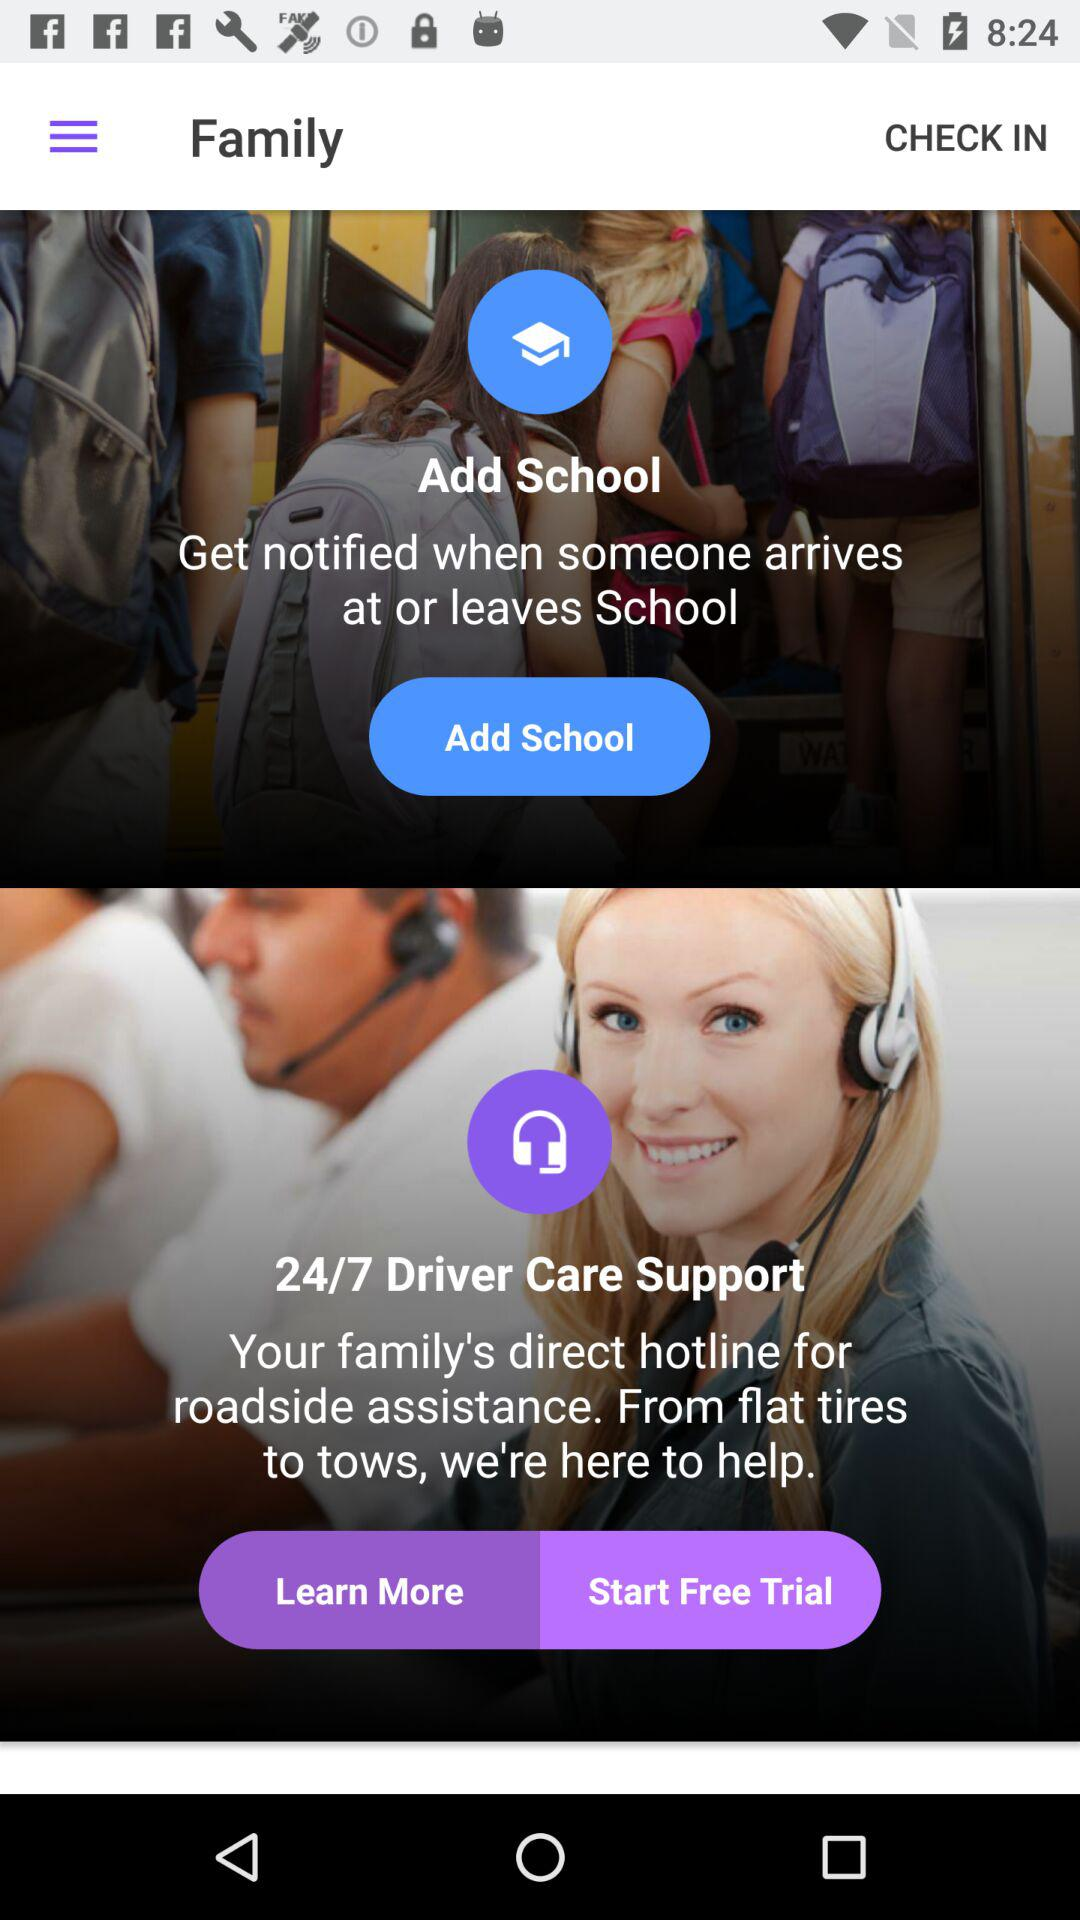What is the time to contact driver care support? The time to contact driver care support is 24/7. 